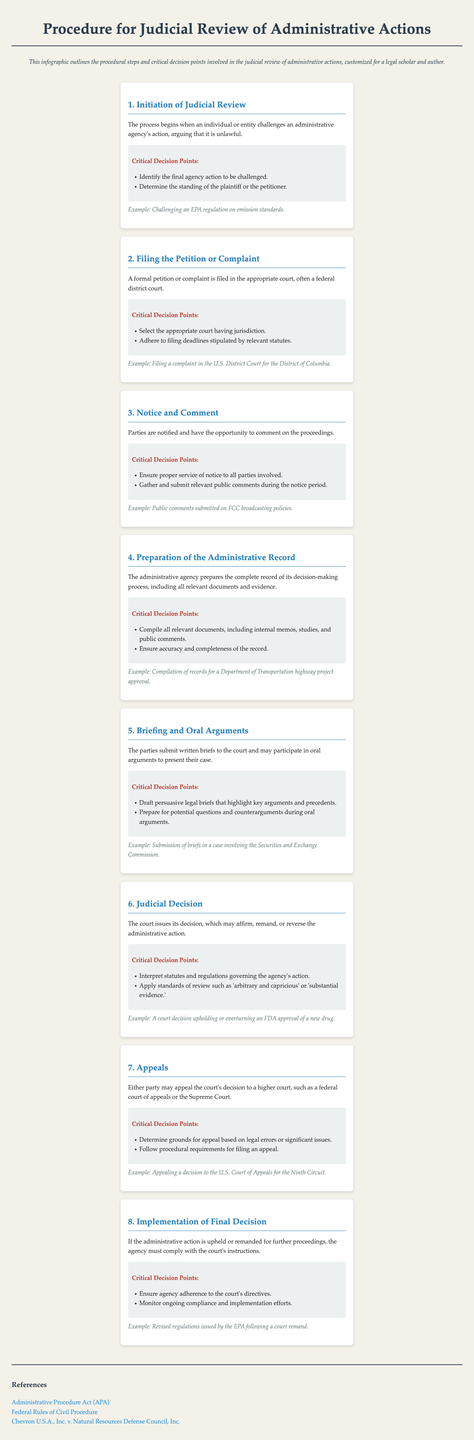What is the first step in the judicial review process? The first step in the judicial review process as outlined is "Initiation of Judicial Review."
Answer: Initiation of Judicial Review Which federal court is often the appropriate venue for filing a complaint? The appropriate federal court for filing a complaint is specified in the step "Filing the Petition or Complaint."
Answer: U.S. District Court What must the administrative agency prepare during the review process? The process step "Preparation of the Administrative Record" indicates that the agency must prepare a complete record of its decision-making process.
Answer: Administrative Record What is the critical decision point during the Briefing and Oral Arguments step? One critical decision point in the "Briefing and Oral Arguments" step is to "Draft persuasive legal briefs that highlight key arguments and precedents."
Answer: Draft persuasive legal briefs What can either party do after the Judicial Decision? The step "Appeals" indicates that either party may appeal the court's decision.
Answer: Appeal What is the final step in the judicial review process? The last step in the process is "Implementation of Final Decision."
Answer: Implementation of Final Decision What precedential case is referenced in the document? The document lists "Chevron U.S.A., Inc. v. Natural Resources Defense Council, Inc." as a referenced case.
Answer: Chevron U.S.A., Inc. v. Natural Resources Defense Council, Inc What must an agency ensure after a court remand? The agency must ensure adherence to the court's directives after a remand, as noted in the final step.
Answer: Adherence to the court's directives 